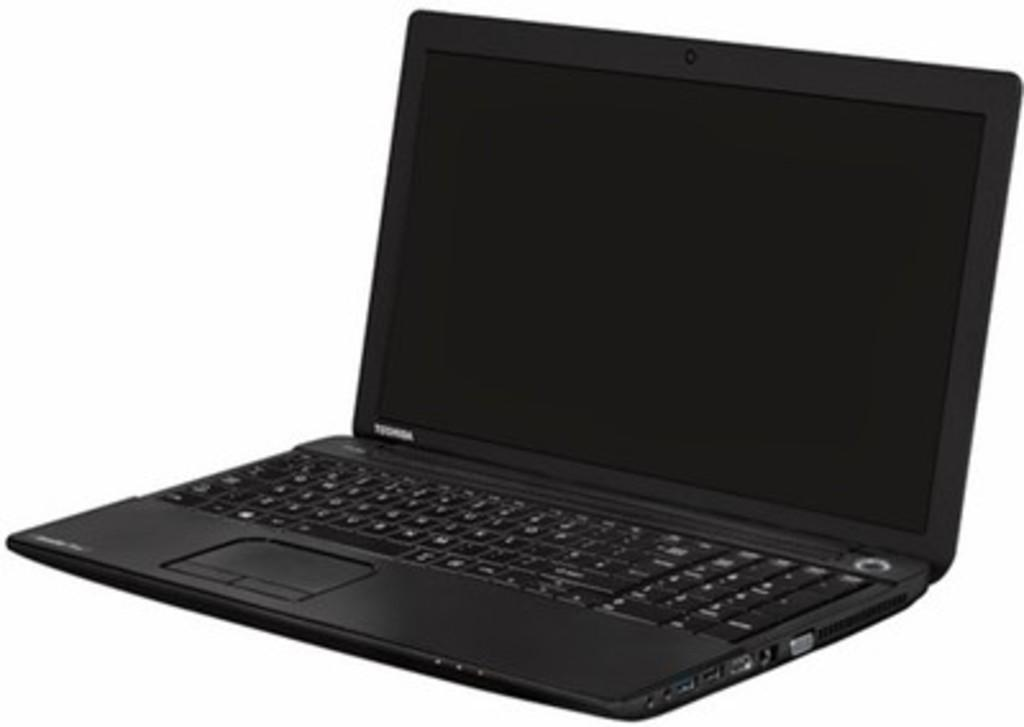Provide a one-sentence caption for the provided image. A black laptop from the computer manufacturer Toshiba. 